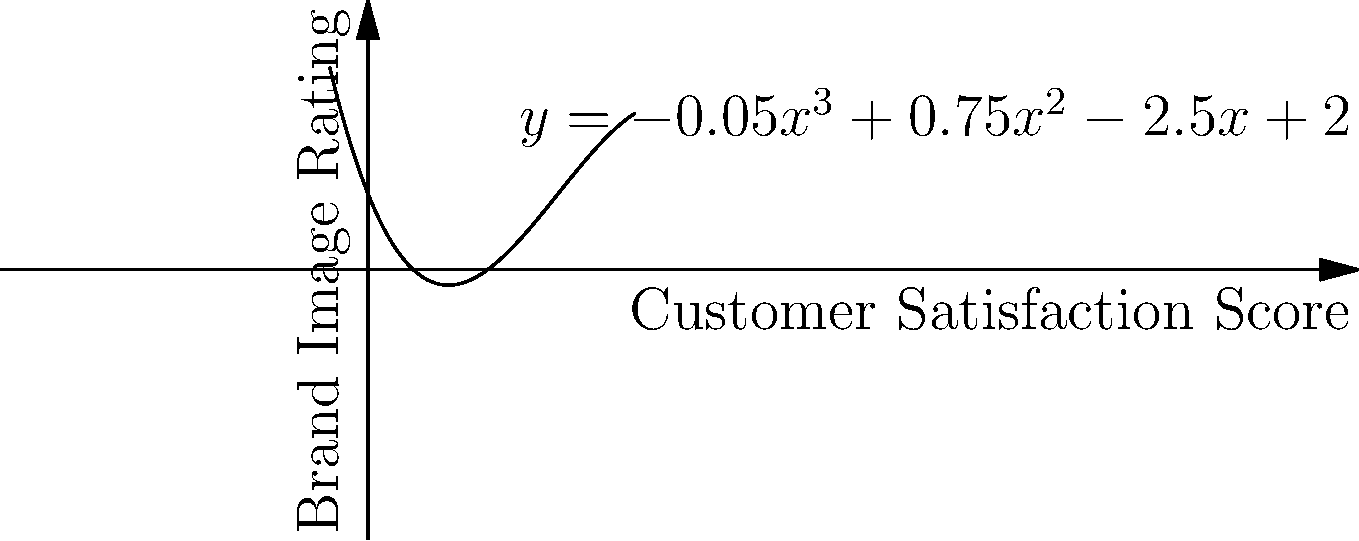As a PR executive, you're analyzing the relationship between customer satisfaction scores and brand image ratings. The polynomial function $y = -0.05x^3 + 0.75x^2 - 2.5x + 2$ models this relationship, where $x$ represents the customer satisfaction score and $y$ represents the brand image rating. Find the customer satisfaction scores that result in a neutral brand image rating (y = 0). How might these points inform your corporate social responsibility strategies? To find the customer satisfaction scores that result in a neutral brand image rating, we need to solve the equation:

$-0.05x^3 + 0.75x^2 - 2.5x + 2 = 0$

1) This is a cubic equation. We can solve it using the following steps:

2) Factor out the greatest common factor:
   $-0.05(x^3 - 15x^2 + 50x - 40) = 0$

3) Use the rational root theorem to find potential roots. The factors of 40 are: ±1, ±2, ±4, ±5, ±8, ±10, ±20, ±40

4) Test these values in the original equation. We find that x = 1 and x = 5 are roots.

5) Since we've found two roots of a cubic equation, we can factor it as:
   $-0.05(x - 1)(x - 5)(x - 8) = 0$

6) Therefore, the roots are x = 1, x = 5, and x = 8.

These points represent the customer satisfaction scores that result in a neutral brand image rating. They can inform corporate social responsibility strategies by:

1. Focusing on improving satisfaction for customers giving scores below 1.
2. Maintaining strategies for customers scoring between 1 and 5.
3. Investigating why high satisfaction (above 8) might lead to decreased brand image.
4. Targeting CSR initiatives to boost scores from 5 to 8 for maximum positive impact.
Answer: x = 1, x = 5, x = 8 